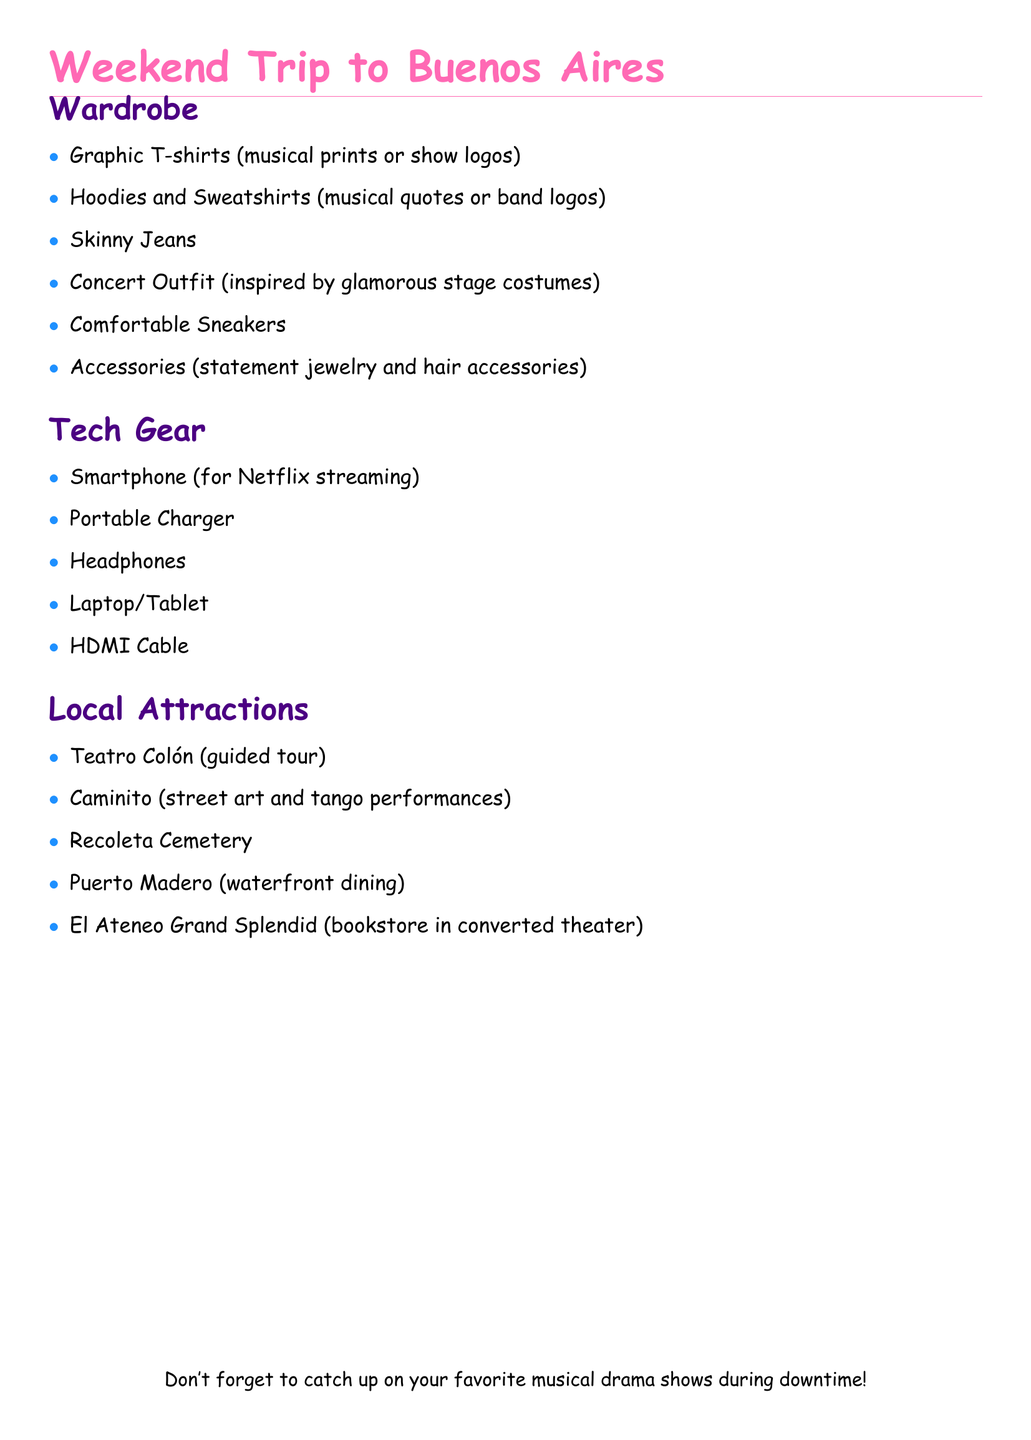What is the wardrobe item inspired by glamorous stage costumes? The document lists a "Concert Outfit" as a wardrobe item inspired by glamorous stage costumes.
Answer: Concert Outfit How many items are listed under Tech Gear? The Tech Gear section includes a total of five items mentioned in the document.
Answer: 5 What type of footwear is recommended for the trip? The document suggests wearing "Comfortable Sneakers" as the type of footwear.
Answer: Comfortable Sneakers Which local attraction is known for street art and tango performances? The local attraction featuring street art and tango performances is "Caminito" according to the document.
Answer: Caminito What accessory should be included in the wardrobe? The document lists "statement jewelry and hair accessories" as accessories to include in the wardrobe.
Answer: statement jewelry and hair accessories Which tech item is essential for Netflix streaming? The document mentions "Smartphone" as the essential tech item for Netflix streaming.
Answer: Smartphone What bookstore is located in a converted theater? The document highlights "El Ateneo Grand Splendid" as a bookstore located in a converted theater.
Answer: El Ateneo Grand Splendid What is the name of the guided tour venue mentioned? The venue for the guided tour mentioned in the document is "Teatro Colón".
Answer: Teatro Colón What is the purpose of the portable charger? The portable charger is intended to keep devices charged during the trip.
Answer: Keep devices charged 